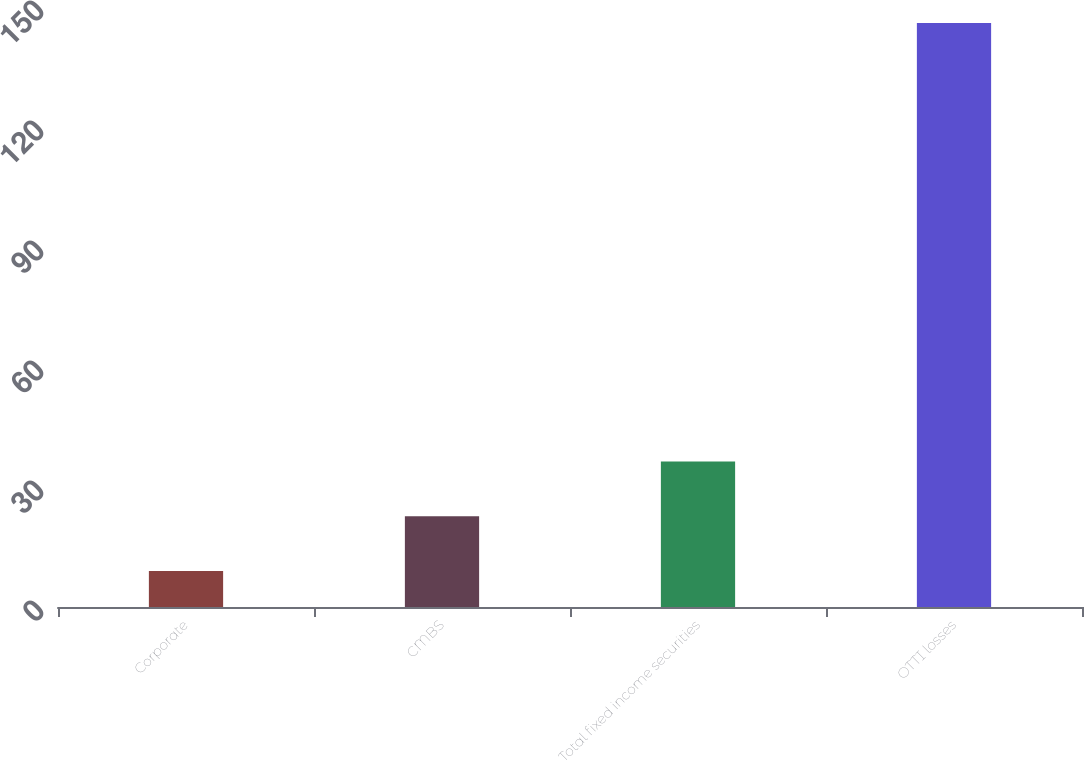<chart> <loc_0><loc_0><loc_500><loc_500><bar_chart><fcel>Corporate<fcel>CMBS<fcel>Total fixed income securities<fcel>OTTI losses<nl><fcel>9<fcel>22.7<fcel>36.4<fcel>146<nl></chart> 